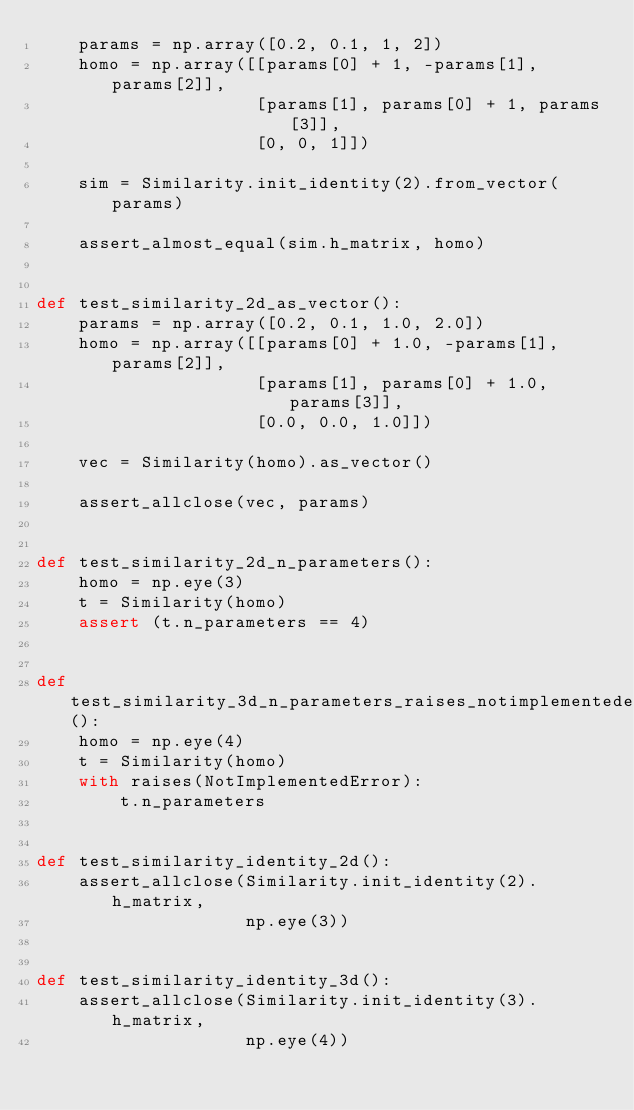<code> <loc_0><loc_0><loc_500><loc_500><_Python_>    params = np.array([0.2, 0.1, 1, 2])
    homo = np.array([[params[0] + 1, -params[1], params[2]],
                     [params[1], params[0] + 1, params[3]],
                     [0, 0, 1]])

    sim = Similarity.init_identity(2).from_vector(params)

    assert_almost_equal(sim.h_matrix, homo)


def test_similarity_2d_as_vector():
    params = np.array([0.2, 0.1, 1.0, 2.0])
    homo = np.array([[params[0] + 1.0, -params[1], params[2]],
                     [params[1], params[0] + 1.0, params[3]],
                     [0.0, 0.0, 1.0]])

    vec = Similarity(homo).as_vector()

    assert_allclose(vec, params)


def test_similarity_2d_n_parameters():
    homo = np.eye(3)
    t = Similarity(homo)
    assert (t.n_parameters == 4)


def test_similarity_3d_n_parameters_raises_notimplementederror():
    homo = np.eye(4)
    t = Similarity(homo)
    with raises(NotImplementedError):
        t.n_parameters


def test_similarity_identity_2d():
    assert_allclose(Similarity.init_identity(2).h_matrix,
                    np.eye(3))


def test_similarity_identity_3d():
    assert_allclose(Similarity.init_identity(3).h_matrix,
                    np.eye(4))
</code> 